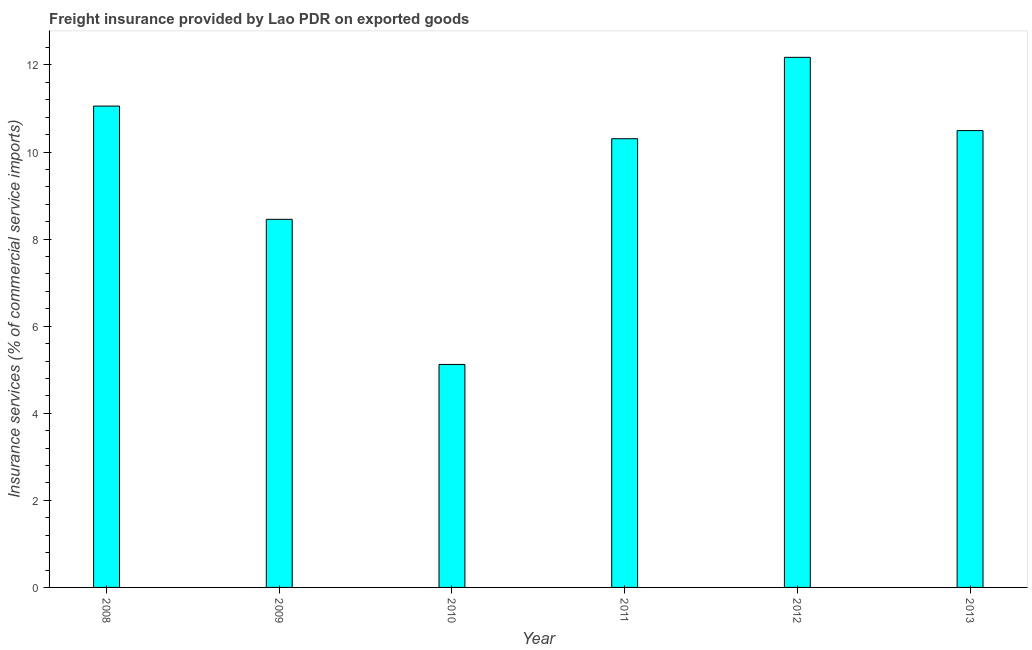Does the graph contain any zero values?
Keep it short and to the point. No. Does the graph contain grids?
Ensure brevity in your answer.  No. What is the title of the graph?
Offer a terse response. Freight insurance provided by Lao PDR on exported goods . What is the label or title of the Y-axis?
Your answer should be compact. Insurance services (% of commercial service imports). What is the freight insurance in 2013?
Your answer should be very brief. 10.49. Across all years, what is the maximum freight insurance?
Offer a terse response. 12.17. Across all years, what is the minimum freight insurance?
Give a very brief answer. 5.12. In which year was the freight insurance maximum?
Provide a short and direct response. 2012. In which year was the freight insurance minimum?
Your answer should be compact. 2010. What is the sum of the freight insurance?
Give a very brief answer. 57.6. What is the difference between the freight insurance in 2008 and 2012?
Your response must be concise. -1.12. What is the median freight insurance?
Make the answer very short. 10.4. In how many years, is the freight insurance greater than 11.2 %?
Provide a succinct answer. 1. What is the ratio of the freight insurance in 2011 to that in 2013?
Your response must be concise. 0.98. Is the freight insurance in 2011 less than that in 2013?
Give a very brief answer. Yes. Is the difference between the freight insurance in 2009 and 2010 greater than the difference between any two years?
Give a very brief answer. No. What is the difference between the highest and the second highest freight insurance?
Your answer should be very brief. 1.12. Is the sum of the freight insurance in 2008 and 2010 greater than the maximum freight insurance across all years?
Your answer should be very brief. Yes. What is the difference between the highest and the lowest freight insurance?
Provide a short and direct response. 7.05. In how many years, is the freight insurance greater than the average freight insurance taken over all years?
Provide a succinct answer. 4. How many bars are there?
Your answer should be very brief. 6. How many years are there in the graph?
Ensure brevity in your answer.  6. What is the Insurance services (% of commercial service imports) of 2008?
Keep it short and to the point. 11.05. What is the Insurance services (% of commercial service imports) of 2009?
Your response must be concise. 8.45. What is the Insurance services (% of commercial service imports) in 2010?
Keep it short and to the point. 5.12. What is the Insurance services (% of commercial service imports) of 2011?
Provide a succinct answer. 10.31. What is the Insurance services (% of commercial service imports) of 2012?
Your answer should be compact. 12.17. What is the Insurance services (% of commercial service imports) of 2013?
Your response must be concise. 10.49. What is the difference between the Insurance services (% of commercial service imports) in 2008 and 2009?
Offer a very short reply. 2.6. What is the difference between the Insurance services (% of commercial service imports) in 2008 and 2010?
Provide a succinct answer. 5.93. What is the difference between the Insurance services (% of commercial service imports) in 2008 and 2011?
Give a very brief answer. 0.75. What is the difference between the Insurance services (% of commercial service imports) in 2008 and 2012?
Your response must be concise. -1.12. What is the difference between the Insurance services (% of commercial service imports) in 2008 and 2013?
Offer a very short reply. 0.56. What is the difference between the Insurance services (% of commercial service imports) in 2009 and 2010?
Keep it short and to the point. 3.33. What is the difference between the Insurance services (% of commercial service imports) in 2009 and 2011?
Offer a very short reply. -1.85. What is the difference between the Insurance services (% of commercial service imports) in 2009 and 2012?
Provide a short and direct response. -3.72. What is the difference between the Insurance services (% of commercial service imports) in 2009 and 2013?
Ensure brevity in your answer.  -2.04. What is the difference between the Insurance services (% of commercial service imports) in 2010 and 2011?
Ensure brevity in your answer.  -5.18. What is the difference between the Insurance services (% of commercial service imports) in 2010 and 2012?
Keep it short and to the point. -7.05. What is the difference between the Insurance services (% of commercial service imports) in 2010 and 2013?
Offer a very short reply. -5.37. What is the difference between the Insurance services (% of commercial service imports) in 2011 and 2012?
Offer a very short reply. -1.87. What is the difference between the Insurance services (% of commercial service imports) in 2011 and 2013?
Provide a short and direct response. -0.19. What is the difference between the Insurance services (% of commercial service imports) in 2012 and 2013?
Your answer should be very brief. 1.68. What is the ratio of the Insurance services (% of commercial service imports) in 2008 to that in 2009?
Offer a very short reply. 1.31. What is the ratio of the Insurance services (% of commercial service imports) in 2008 to that in 2010?
Your answer should be very brief. 2.16. What is the ratio of the Insurance services (% of commercial service imports) in 2008 to that in 2011?
Keep it short and to the point. 1.07. What is the ratio of the Insurance services (% of commercial service imports) in 2008 to that in 2012?
Offer a terse response. 0.91. What is the ratio of the Insurance services (% of commercial service imports) in 2008 to that in 2013?
Offer a terse response. 1.05. What is the ratio of the Insurance services (% of commercial service imports) in 2009 to that in 2010?
Keep it short and to the point. 1.65. What is the ratio of the Insurance services (% of commercial service imports) in 2009 to that in 2011?
Give a very brief answer. 0.82. What is the ratio of the Insurance services (% of commercial service imports) in 2009 to that in 2012?
Keep it short and to the point. 0.69. What is the ratio of the Insurance services (% of commercial service imports) in 2009 to that in 2013?
Ensure brevity in your answer.  0.81. What is the ratio of the Insurance services (% of commercial service imports) in 2010 to that in 2011?
Ensure brevity in your answer.  0.5. What is the ratio of the Insurance services (% of commercial service imports) in 2010 to that in 2012?
Give a very brief answer. 0.42. What is the ratio of the Insurance services (% of commercial service imports) in 2010 to that in 2013?
Give a very brief answer. 0.49. What is the ratio of the Insurance services (% of commercial service imports) in 2011 to that in 2012?
Keep it short and to the point. 0.85. What is the ratio of the Insurance services (% of commercial service imports) in 2011 to that in 2013?
Provide a succinct answer. 0.98. What is the ratio of the Insurance services (% of commercial service imports) in 2012 to that in 2013?
Give a very brief answer. 1.16. 